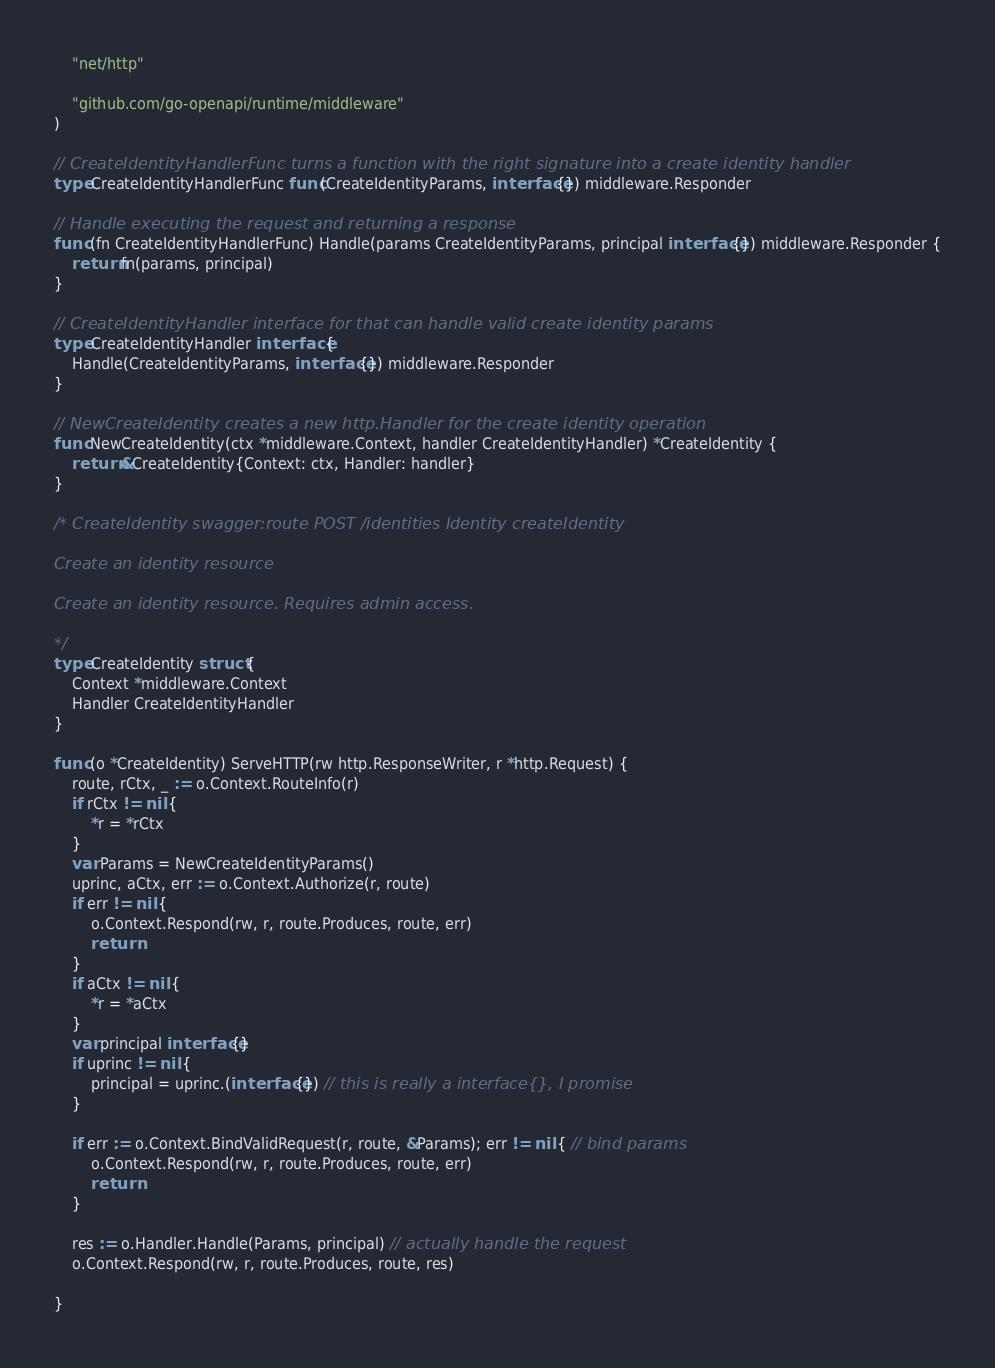Convert code to text. <code><loc_0><loc_0><loc_500><loc_500><_Go_>	"net/http"

	"github.com/go-openapi/runtime/middleware"
)

// CreateIdentityHandlerFunc turns a function with the right signature into a create identity handler
type CreateIdentityHandlerFunc func(CreateIdentityParams, interface{}) middleware.Responder

// Handle executing the request and returning a response
func (fn CreateIdentityHandlerFunc) Handle(params CreateIdentityParams, principal interface{}) middleware.Responder {
	return fn(params, principal)
}

// CreateIdentityHandler interface for that can handle valid create identity params
type CreateIdentityHandler interface {
	Handle(CreateIdentityParams, interface{}) middleware.Responder
}

// NewCreateIdentity creates a new http.Handler for the create identity operation
func NewCreateIdentity(ctx *middleware.Context, handler CreateIdentityHandler) *CreateIdentity {
	return &CreateIdentity{Context: ctx, Handler: handler}
}

/* CreateIdentity swagger:route POST /identities Identity createIdentity

Create an identity resource

Create an identity resource. Requires admin access.

*/
type CreateIdentity struct {
	Context *middleware.Context
	Handler CreateIdentityHandler
}

func (o *CreateIdentity) ServeHTTP(rw http.ResponseWriter, r *http.Request) {
	route, rCtx, _ := o.Context.RouteInfo(r)
	if rCtx != nil {
		*r = *rCtx
	}
	var Params = NewCreateIdentityParams()
	uprinc, aCtx, err := o.Context.Authorize(r, route)
	if err != nil {
		o.Context.Respond(rw, r, route.Produces, route, err)
		return
	}
	if aCtx != nil {
		*r = *aCtx
	}
	var principal interface{}
	if uprinc != nil {
		principal = uprinc.(interface{}) // this is really a interface{}, I promise
	}

	if err := o.Context.BindValidRequest(r, route, &Params); err != nil { // bind params
		o.Context.Respond(rw, r, route.Produces, route, err)
		return
	}

	res := o.Handler.Handle(Params, principal) // actually handle the request
	o.Context.Respond(rw, r, route.Produces, route, res)

}
</code> 